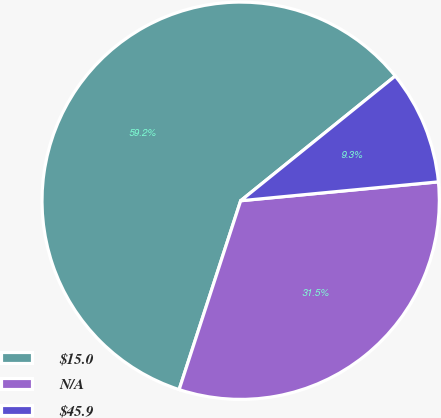Convert chart to OTSL. <chart><loc_0><loc_0><loc_500><loc_500><pie_chart><fcel>$15.0<fcel>N/A<fcel>$45.9<nl><fcel>59.18%<fcel>31.53%<fcel>9.29%<nl></chart> 